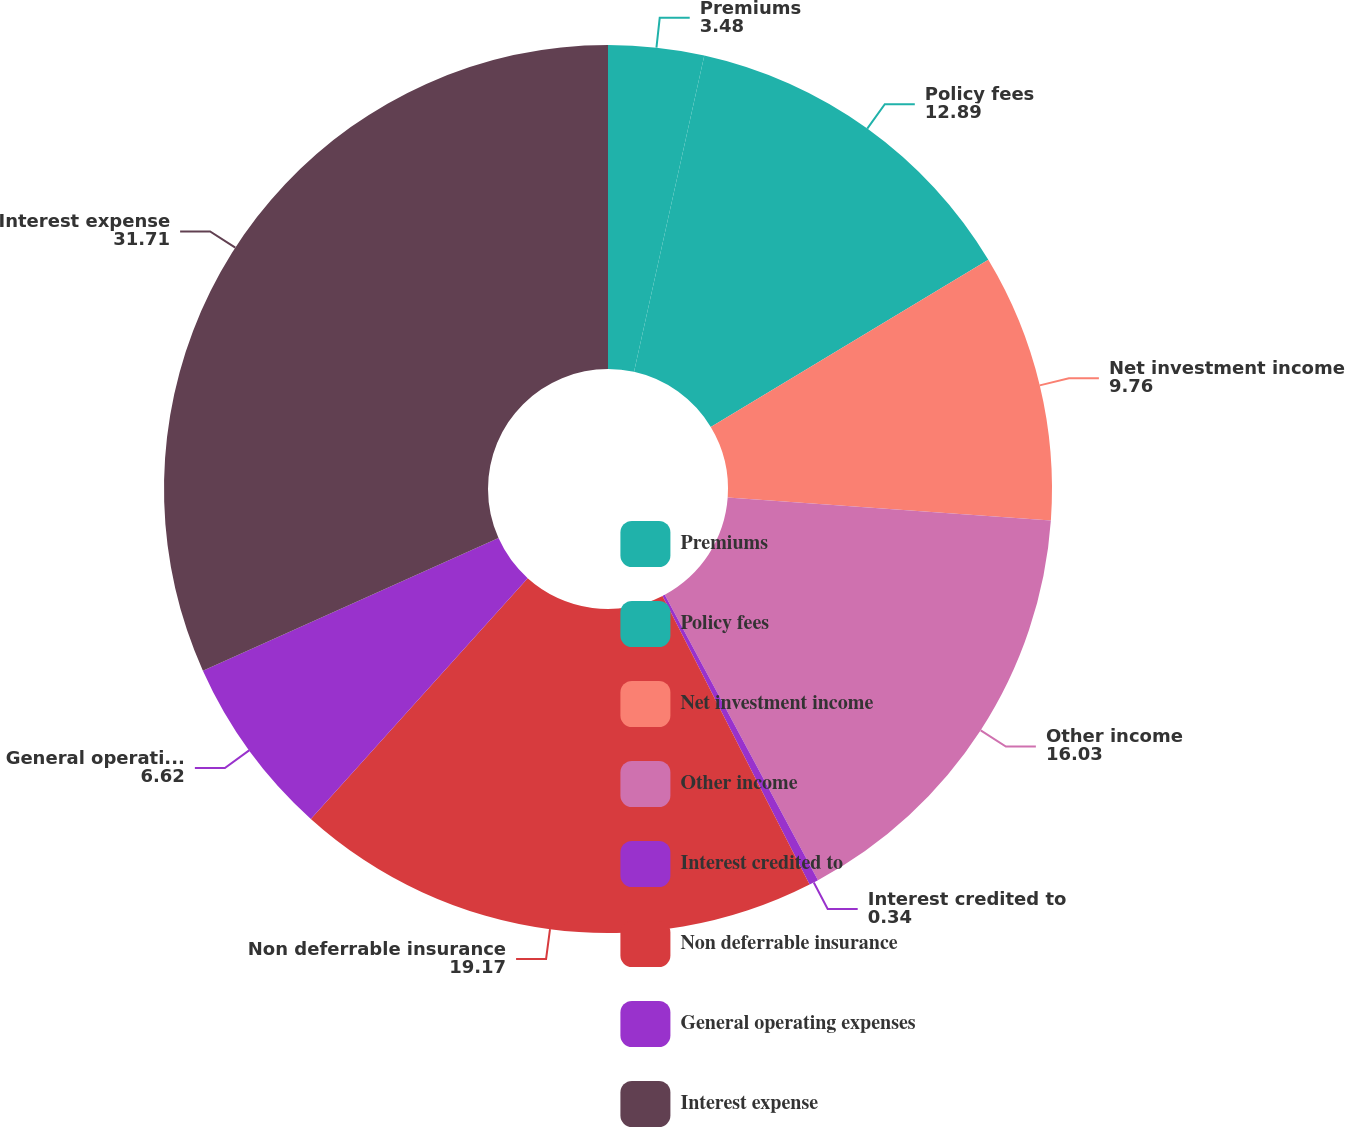Convert chart. <chart><loc_0><loc_0><loc_500><loc_500><pie_chart><fcel>Premiums<fcel>Policy fees<fcel>Net investment income<fcel>Other income<fcel>Interest credited to<fcel>Non deferrable insurance<fcel>General operating expenses<fcel>Interest expense<nl><fcel>3.48%<fcel>12.89%<fcel>9.76%<fcel>16.03%<fcel>0.34%<fcel>19.17%<fcel>6.62%<fcel>31.71%<nl></chart> 